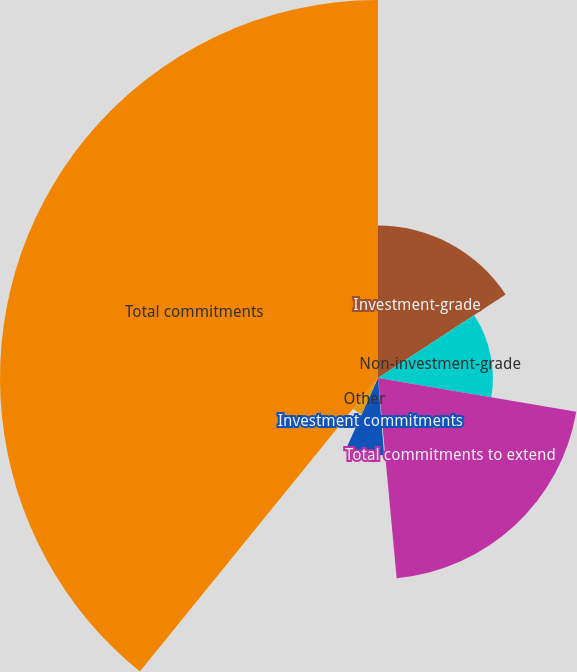Convert chart to OTSL. <chart><loc_0><loc_0><loc_500><loc_500><pie_chart><fcel>Investment-grade<fcel>Non-investment-grade<fcel>Total commitments to extend<fcel>Letters of credit 1<fcel>Investment commitments<fcel>Other<fcel>Total commitments<nl><fcel>15.79%<fcel>11.9%<fcel>20.83%<fcel>0.22%<fcel>8.0%<fcel>4.11%<fcel>39.15%<nl></chart> 